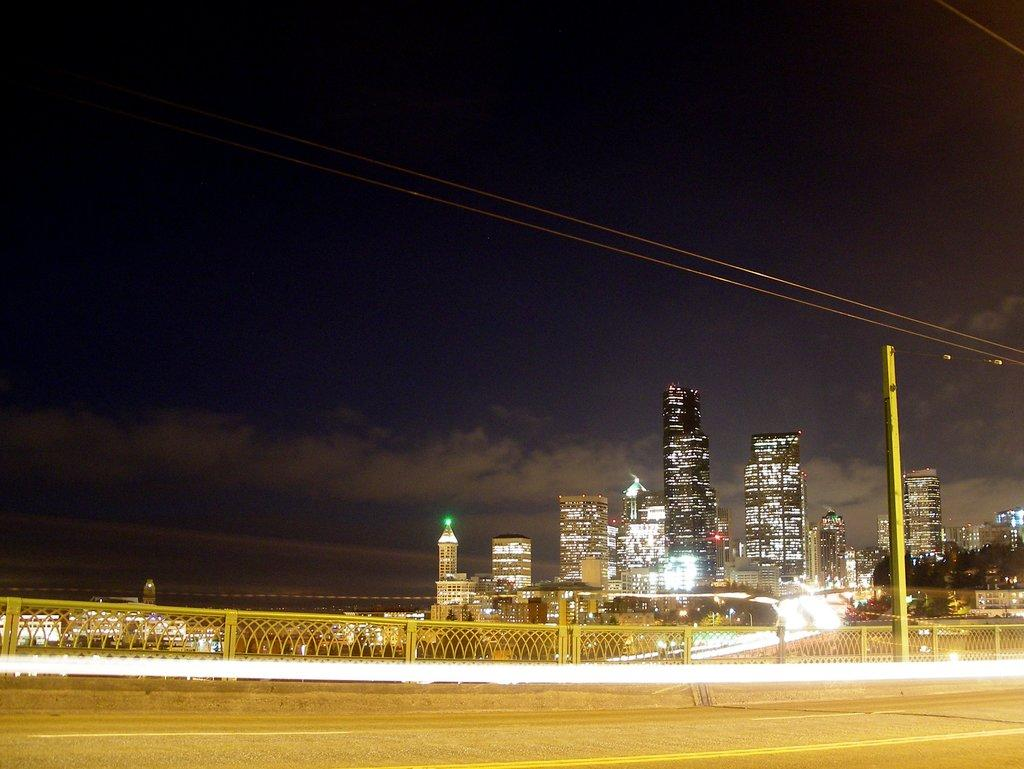What is located in the foreground of the image? There is a road, a railing, and a pole in the foreground of the image. What can be seen in the background of the image? There are buildings, skyscrapers, and a dark sky with a cloud visible in the background of the image. How does the heat affect the grip of the railing in the image? There is no information about heat in the image, and therefore we cannot determine its effect on the railing's grip. What type of loss is depicted in the image? There is no depiction of loss in the image; it features a road, railing, pole, buildings, skyscrapers, and a dark sky with a cloud. 